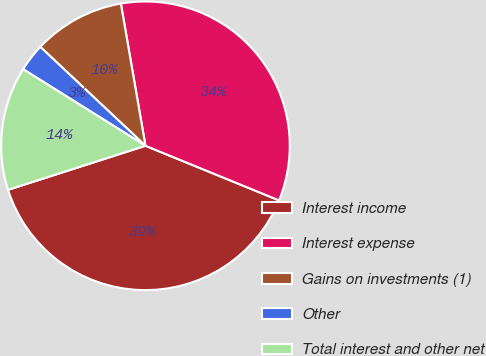Convert chart. <chart><loc_0><loc_0><loc_500><loc_500><pie_chart><fcel>Interest income<fcel>Interest expense<fcel>Gains on investments (1)<fcel>Other<fcel>Total interest and other net<nl><fcel>38.88%<fcel>33.9%<fcel>10.26%<fcel>3.11%<fcel>13.84%<nl></chart> 